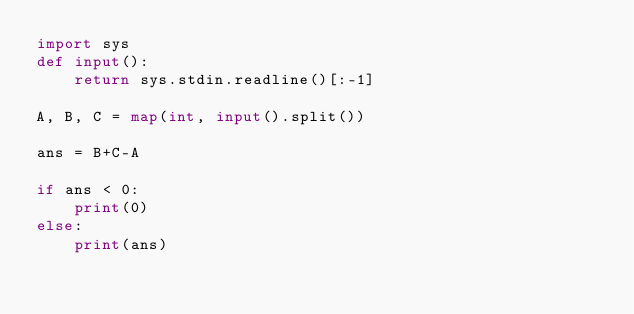Convert code to text. <code><loc_0><loc_0><loc_500><loc_500><_Python_>import sys
def input():
    return sys.stdin.readline()[:-1]

A, B, C = map(int, input().split())

ans = B+C-A

if ans < 0:
    print(0)
else:
    print(ans)</code> 